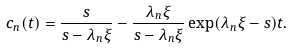<formula> <loc_0><loc_0><loc_500><loc_500>c _ { n } ( t ) = \frac { s } { s - \lambda _ { n } \xi } - \frac { \lambda _ { n } \xi } { s - \lambda _ { n } \xi } \exp ( \lambda _ { n } \xi - s ) t .</formula> 